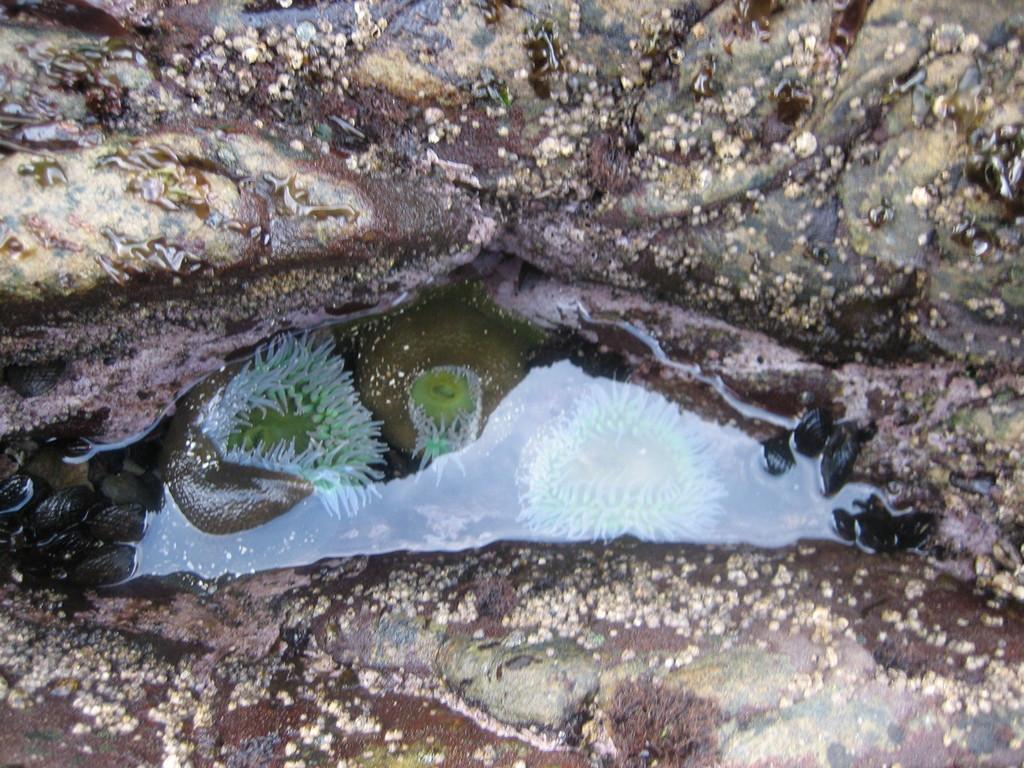In one or two sentences, can you explain what this image depicts? In this image there are rocks. In the center there is the water. In the water there are marine organisms. 